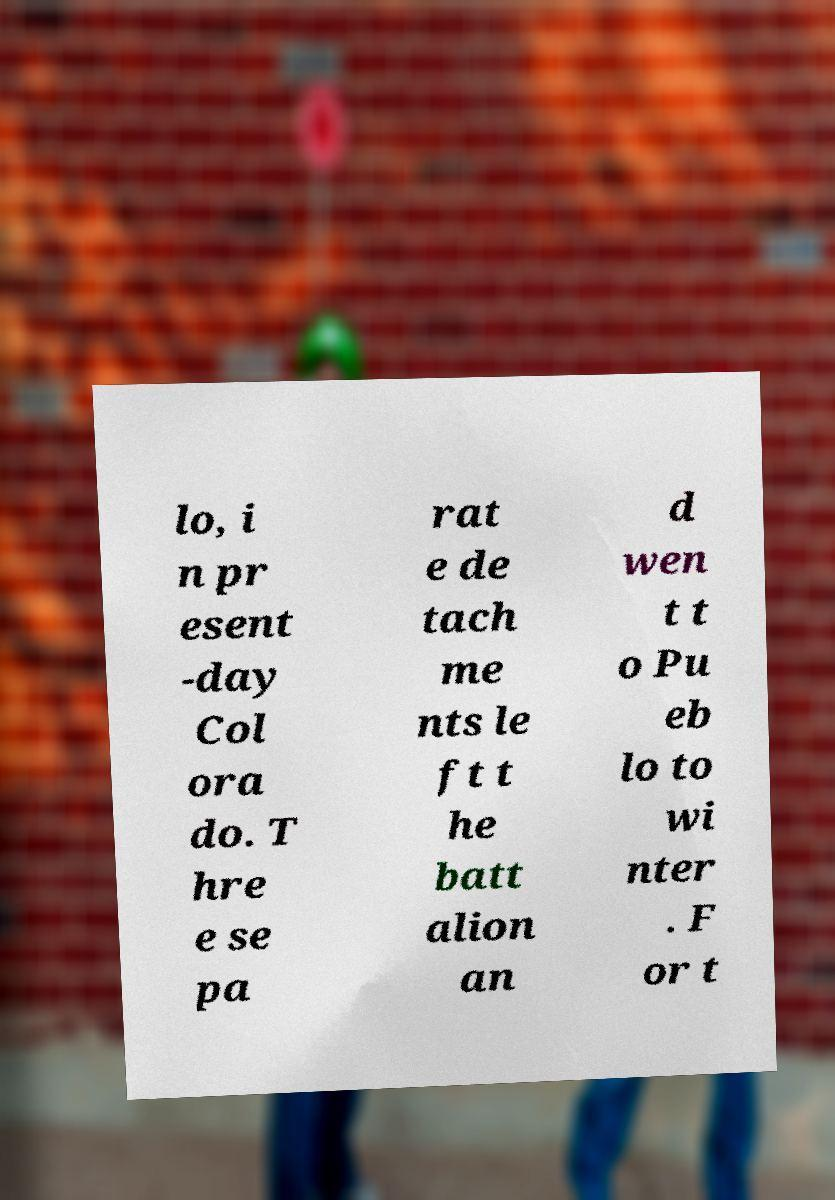I need the written content from this picture converted into text. Can you do that? lo, i n pr esent -day Col ora do. T hre e se pa rat e de tach me nts le ft t he batt alion an d wen t t o Pu eb lo to wi nter . F or t 